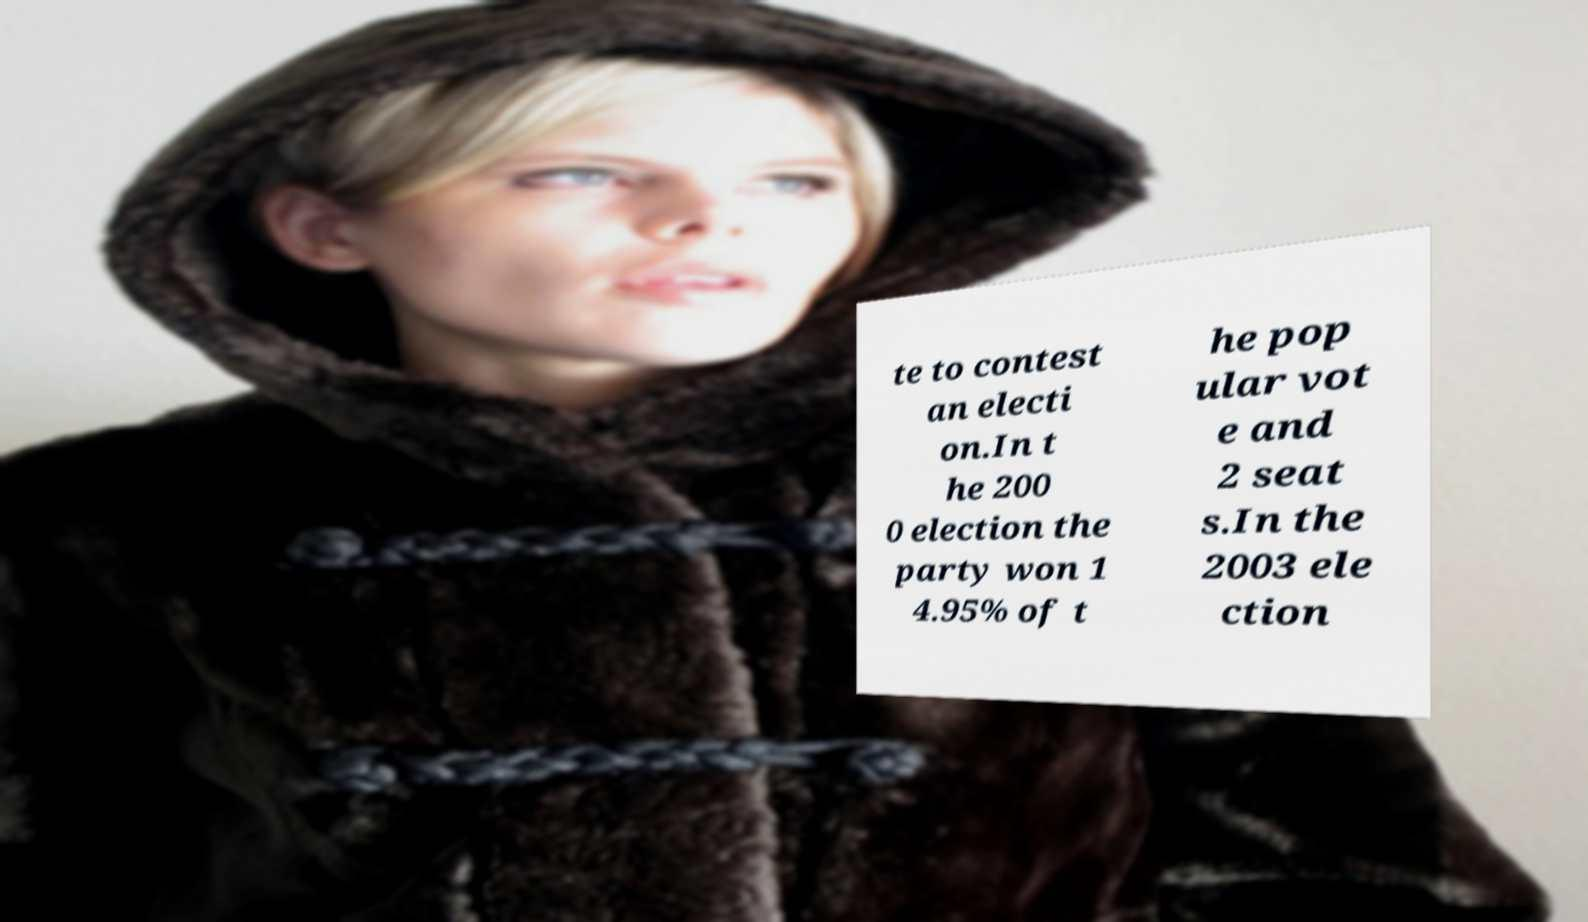Could you assist in decoding the text presented in this image and type it out clearly? te to contest an electi on.In t he 200 0 election the party won 1 4.95% of t he pop ular vot e and 2 seat s.In the 2003 ele ction 